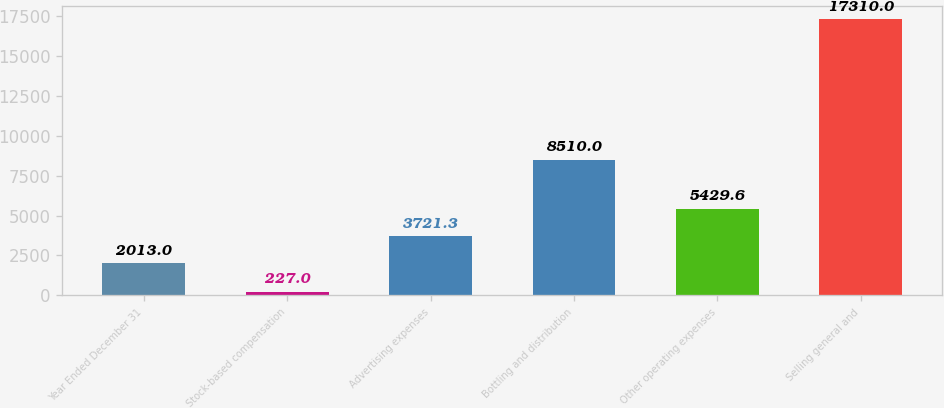<chart> <loc_0><loc_0><loc_500><loc_500><bar_chart><fcel>Year Ended December 31<fcel>Stock-based compensation<fcel>Advertising expenses<fcel>Bottling and distribution<fcel>Other operating expenses<fcel>Selling general and<nl><fcel>2013<fcel>227<fcel>3721.3<fcel>8510<fcel>5429.6<fcel>17310<nl></chart> 